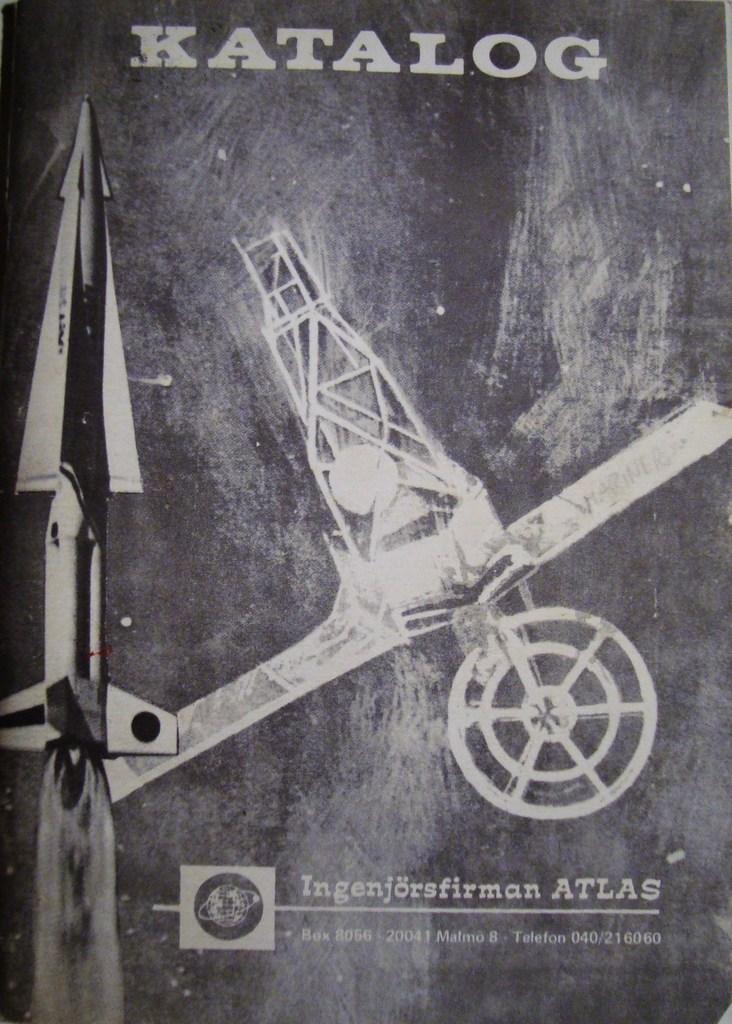Can you describe this image briefly? This is a black and white poster. ''Katalog'' is written on the top. There are 2 aeroplanes at the centers. 